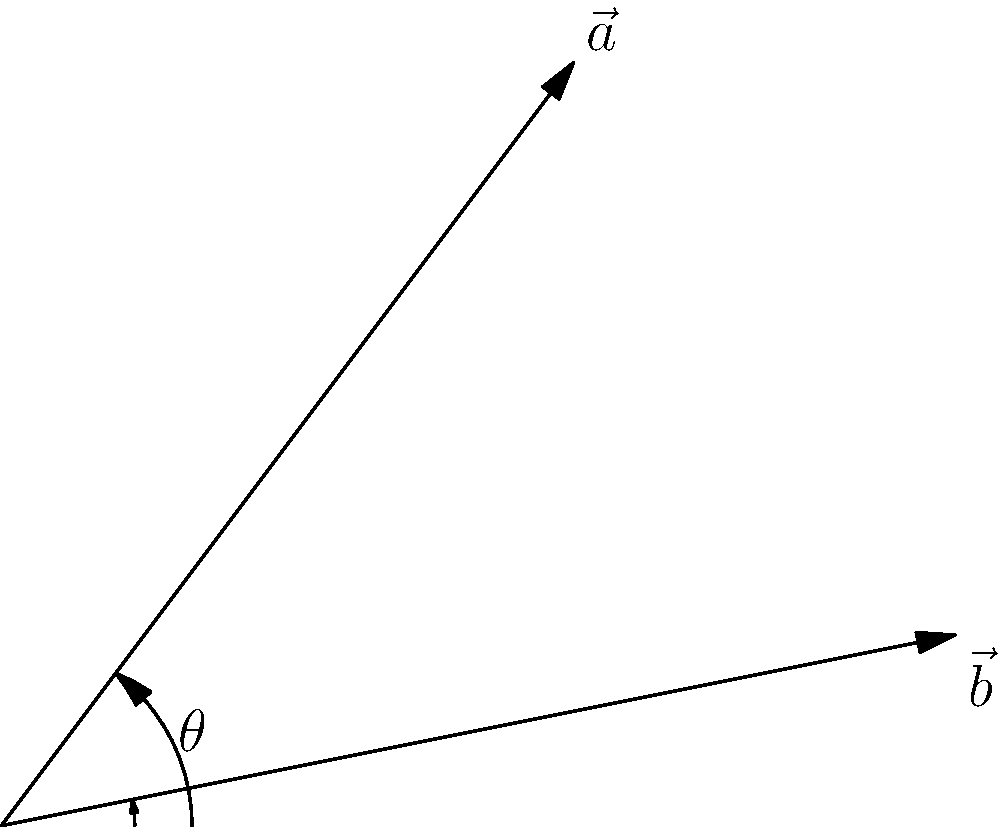Two eco-friendly paint brushes are represented by vectors $\vec{a} = (3, 4)$ and $\vec{b} = (5, 1)$. Calculate the angle $\theta$ between these vectors, representing the diversity in your cruelty-free art tool collection. To find the angle between two vectors, we can use the dot product formula:

$$\cos \theta = \frac{\vec{a} \cdot \vec{b}}{|\vec{a}||\vec{b}|}$$

Step 1: Calculate the dot product $\vec{a} \cdot \vec{b}$
$\vec{a} \cdot \vec{b} = (3 \times 5) + (4 \times 1) = 15 + 4 = 19$

Step 2: Calculate the magnitudes of the vectors
$|\vec{a}| = \sqrt{3^2 + 4^2} = \sqrt{9 + 16} = \sqrt{25} = 5$
$|\vec{b}| = \sqrt{5^2 + 1^2} = \sqrt{25 + 1} = \sqrt{26}$

Step 3: Apply the formula
$$\cos \theta = \frac{19}{5\sqrt{26}}$$

Step 4: Take the inverse cosine (arccos) of both sides
$$\theta = \arccos\left(\frac{19}{5\sqrt{26}}\right)$$

Step 5: Calculate the result (in radians)
$$\theta \approx 0.3398 \text{ radians}$$

Step 6: Convert to degrees
$$\theta \approx 0.3398 \times \frac{180}{\pi} \approx 19.47°$$
Answer: 19.47° 